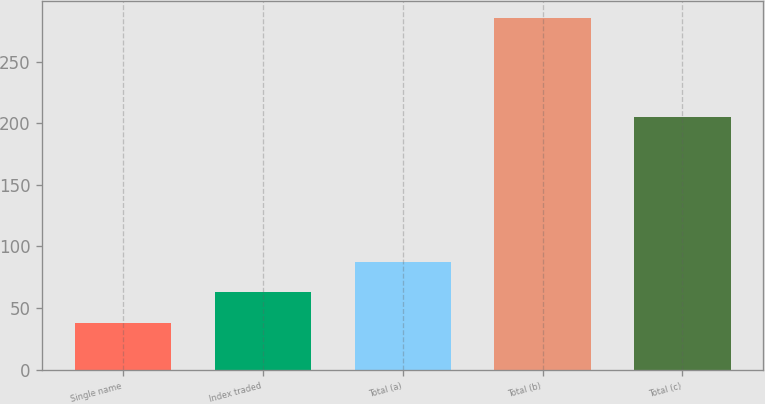Convert chart to OTSL. <chart><loc_0><loc_0><loc_500><loc_500><bar_chart><fcel>Single name<fcel>Index traded<fcel>Total (a)<fcel>Total (b)<fcel>Total (c)<nl><fcel>38<fcel>62.7<fcel>87.4<fcel>285<fcel>205<nl></chart> 